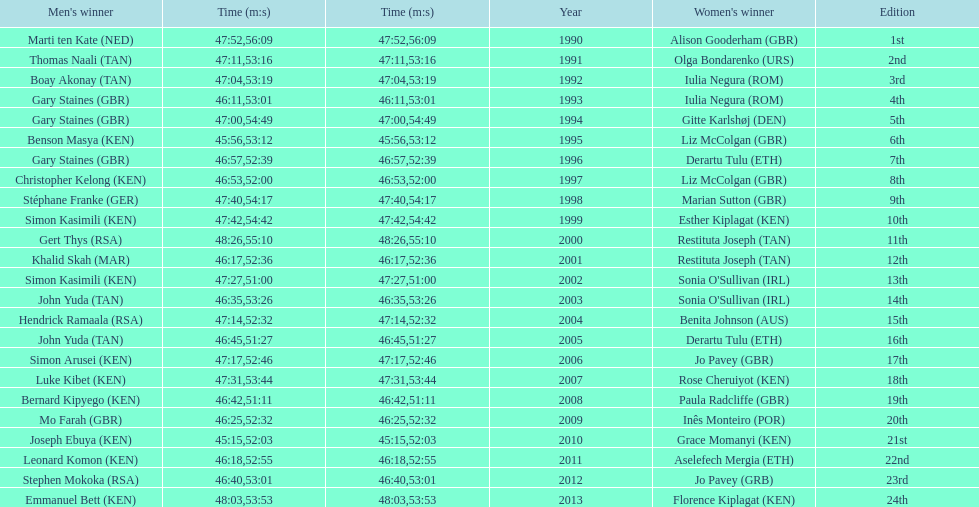What is the name of the first women's winner? Alison Gooderham. 